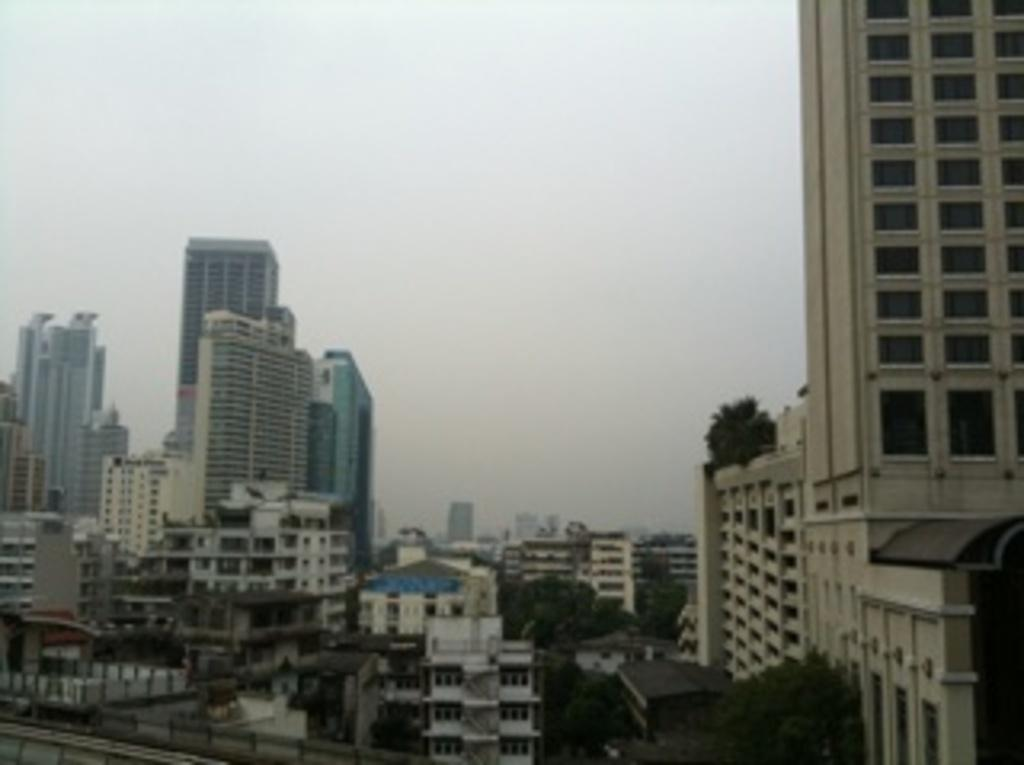What type of structures can be seen in the image? There are buildings in the image. What type of vegetation is present in the image? There are trees in the image. What type of vessel is being used to collect blood in the image? There is no vessel or blood present in the image; it only features buildings and trees. 